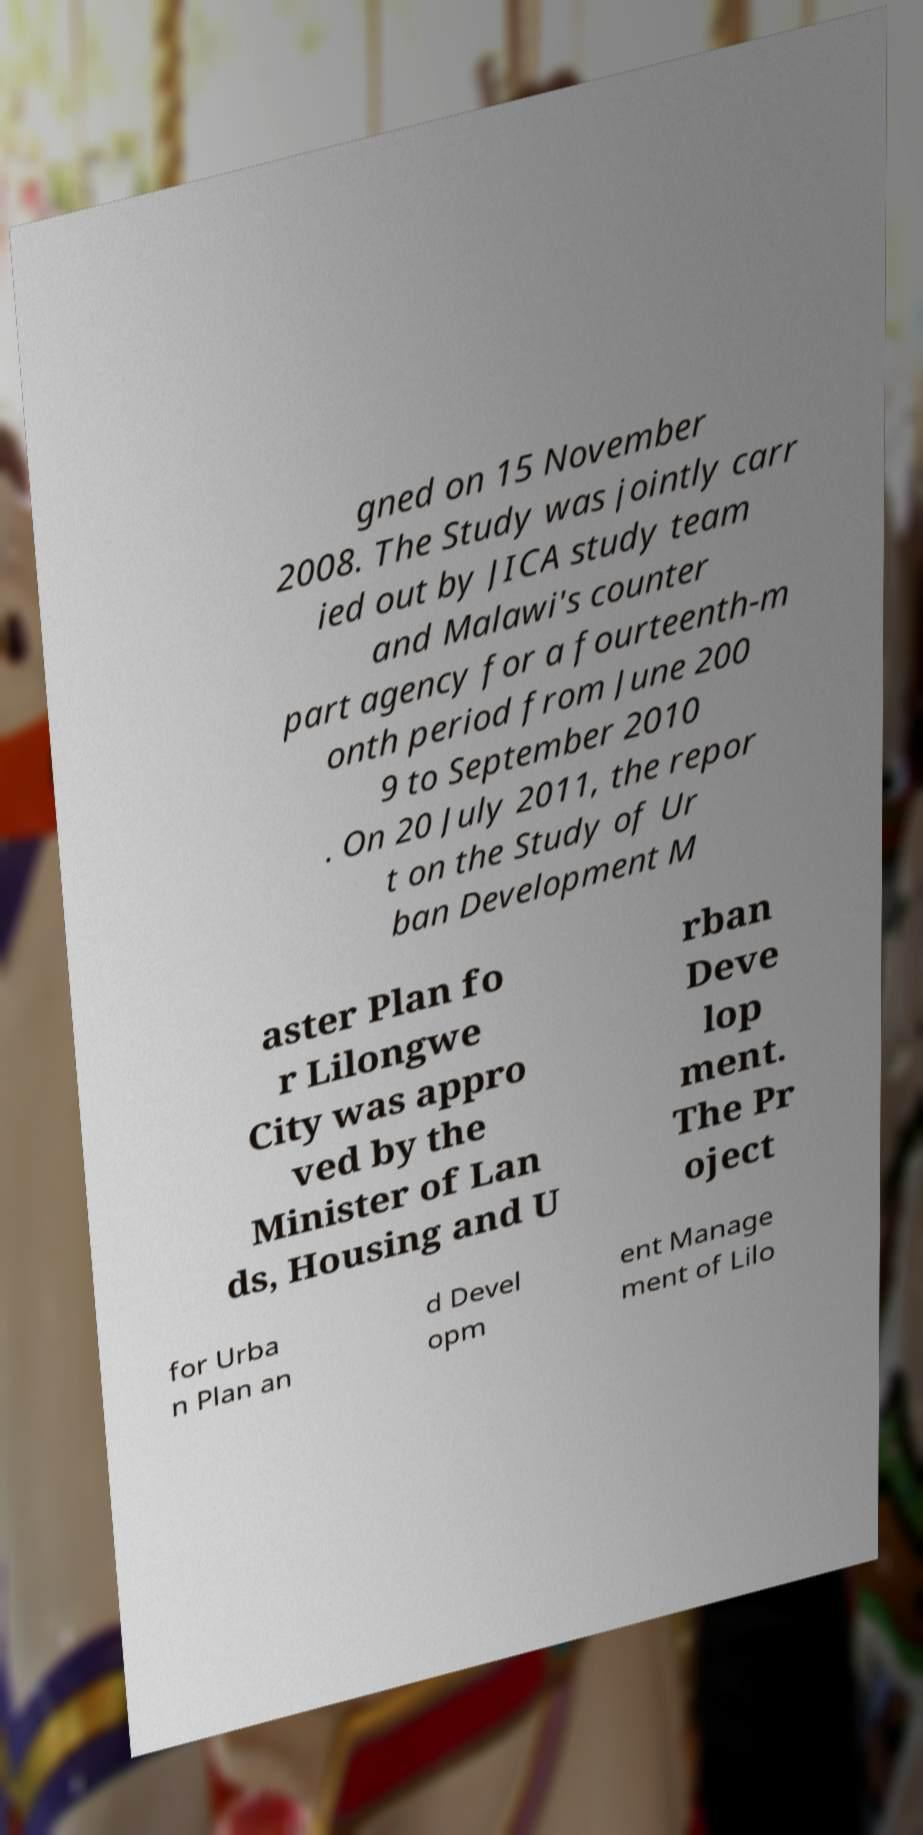Can you read and provide the text displayed in the image?This photo seems to have some interesting text. Can you extract and type it out for me? gned on 15 November 2008. The Study was jointly carr ied out by JICA study team and Malawi's counter part agency for a fourteenth-m onth period from June 200 9 to September 2010 . On 20 July 2011, the repor t on the Study of Ur ban Development M aster Plan fo r Lilongwe City was appro ved by the Minister of Lan ds, Housing and U rban Deve lop ment. The Pr oject for Urba n Plan an d Devel opm ent Manage ment of Lilo 